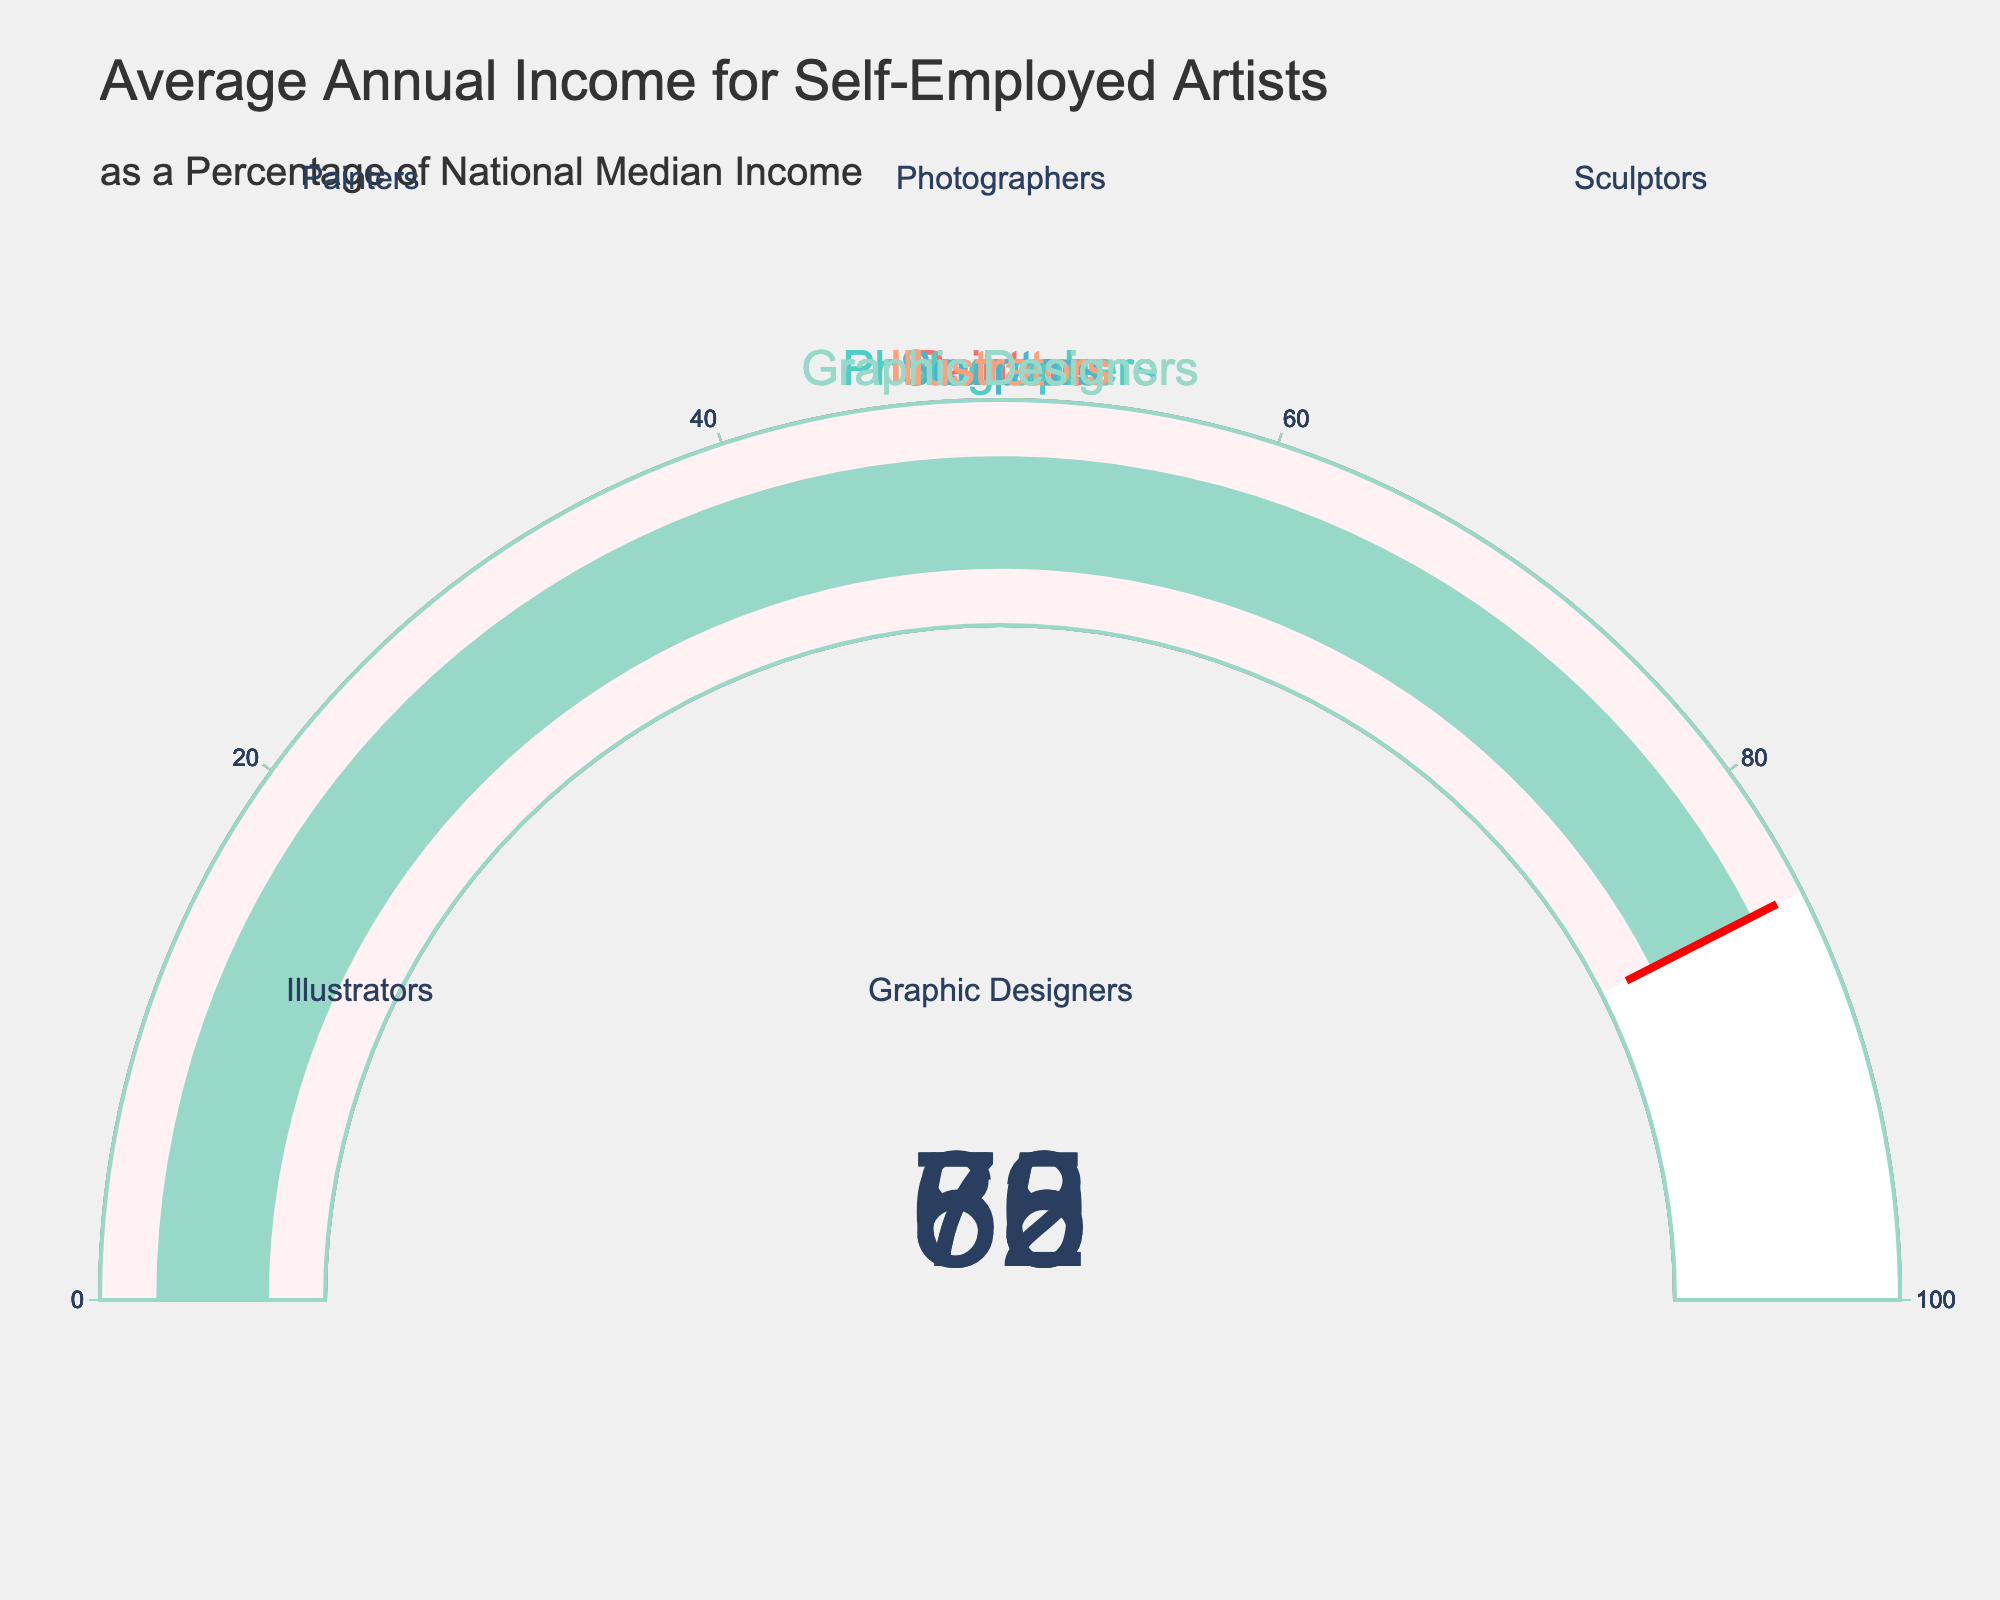What's the title of the figure? The title is prominently displayed at the top of the figure and reads "Average Annual Income for Self-Employed Artists as a Percentage of National Median Income".
Answer: Average Annual Income for Self-Employed Artists as a Percentage of National Median Income What is the value shown for Painters? The gauge chart labeled "Painters" shows a percentage value, which can be read directly from the gauge number.
Answer: 65 How many categories of artists are shown in the figure? The subplot titles and gauges correspond to different categories. Counting them, we find the categories listed are Painters, Photographers, Sculptors, Illustrators, and Graphic Designers.
Answer: 5 What's the difference between the highest and lowest values displayed? The highest value is for Graphic Designers (85) and the lowest is for Sculptors (58). The difference can be calculated as 85 - 58.
Answer: 27 Which category has the highest average annual income as a percentage of the national median income? By comparing all the gauge values, the highest number is for Graphic Designers with a value of 85.
Answer: Graphic Designers How does the value for Illustrators compare to that of Photographers? The value for Illustrators is 70, while the value for Photographers is 72. Thus, Photographers have a slightly higher percentage.
Answer: Photographers have a higher percentage If we average the percentages for Painters and Sculptors, what do we get? The values for Painters and Sculptors are 65 and 58 respectively. The average is calculated as (65 + 58) / 2.
Answer: 61.5 Which categories have values above 70? The gauges for Photographers (72) and Graphic Designers (85) show values above 70.
Answer: Photographers, Graphic Designers Are there any categories with a value below 60? Sculptors have a value of 58, which is the only value below 60 in the figure.
Answer: Sculptors What's the sum of the values for all categories? Adding the values of Painters (65), Photographers (72), Sculptors (58), Illustrators (70), and Graphic Designers (85) gives us the total sum.
Answer: 350 